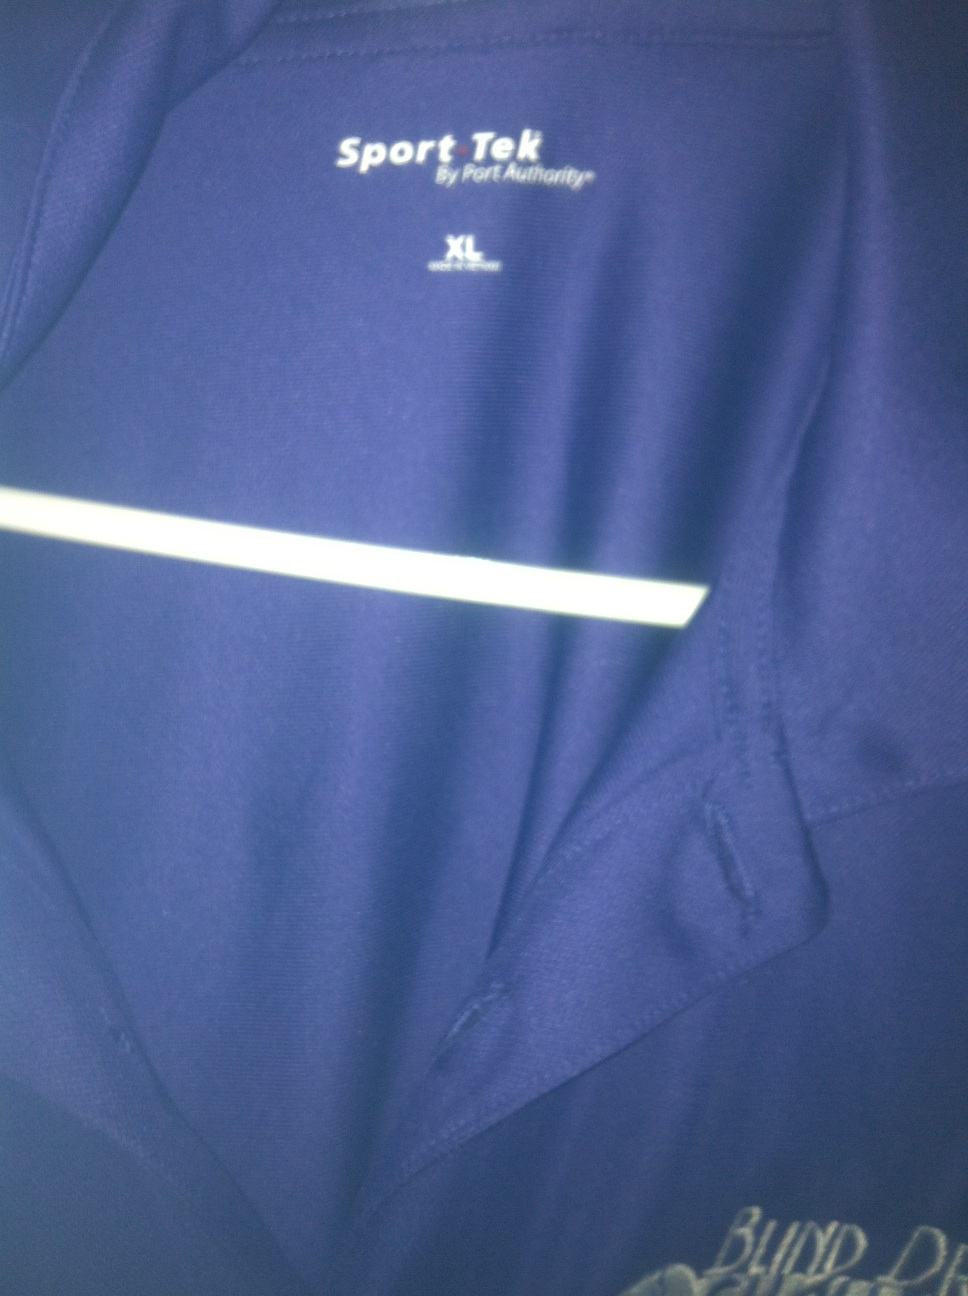What kind of material might this shirt be made of, based on its appearance? The shirt appears to be made from a synthetic fabric, possibly a polyester blend, which is common for sports apparel. These materials are chosen for their durability, moisture-wicking properties, and ability to retain color and shape over time, making them ideal for active wear. 